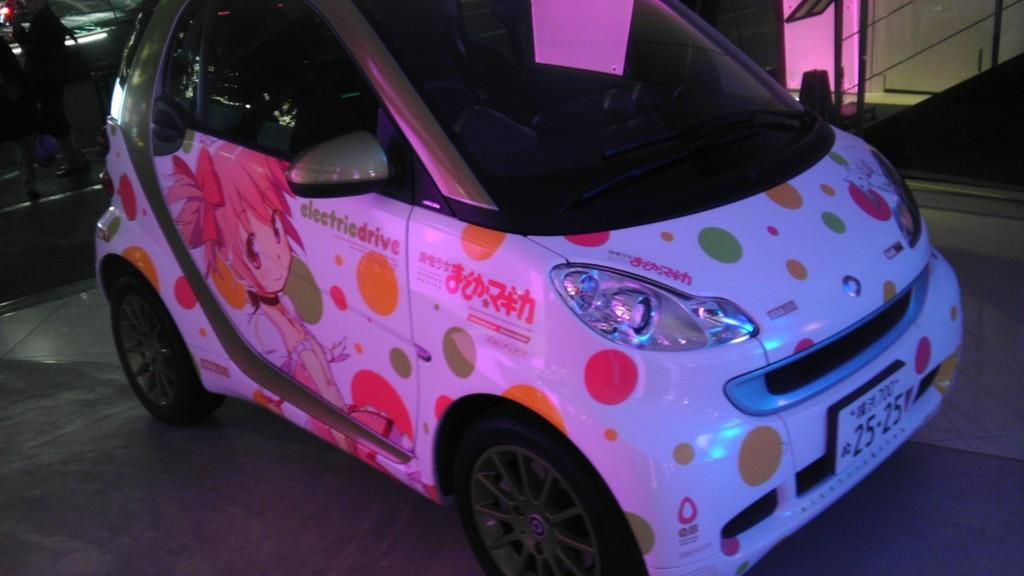What is the main subject of the image? The main subject of the image is a car. What can be seen on the car? The car has an image on it. Is the car in motion or stationary in the image? The car is parked in the image. What is the color of the background in the image? The background of the image is dark. What type of suit is the car wearing in the image? Cars do not wear suits; the question is not applicable to the image. Can you tell me how many buttons are on the front of the car in the image? Cars do not have buttons, so this question cannot be answered based on the image. 